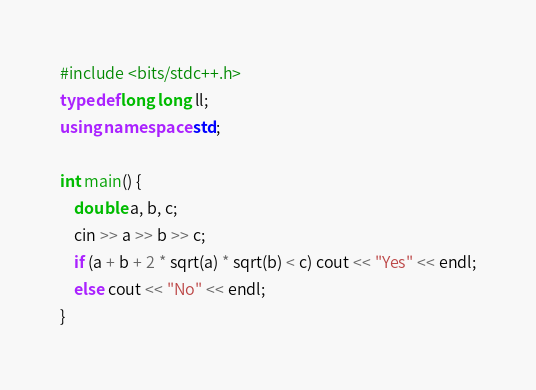Convert code to text. <code><loc_0><loc_0><loc_500><loc_500><_C++_>#include <bits/stdc++.h>
typedef long long ll;
using namespace std;

int main() {
    double a, b, c;
    cin >> a >> b >> c;
    if (a + b + 2 * sqrt(a) * sqrt(b) < c) cout << "Yes" << endl;
    else cout << "No" << endl;
}
</code> 